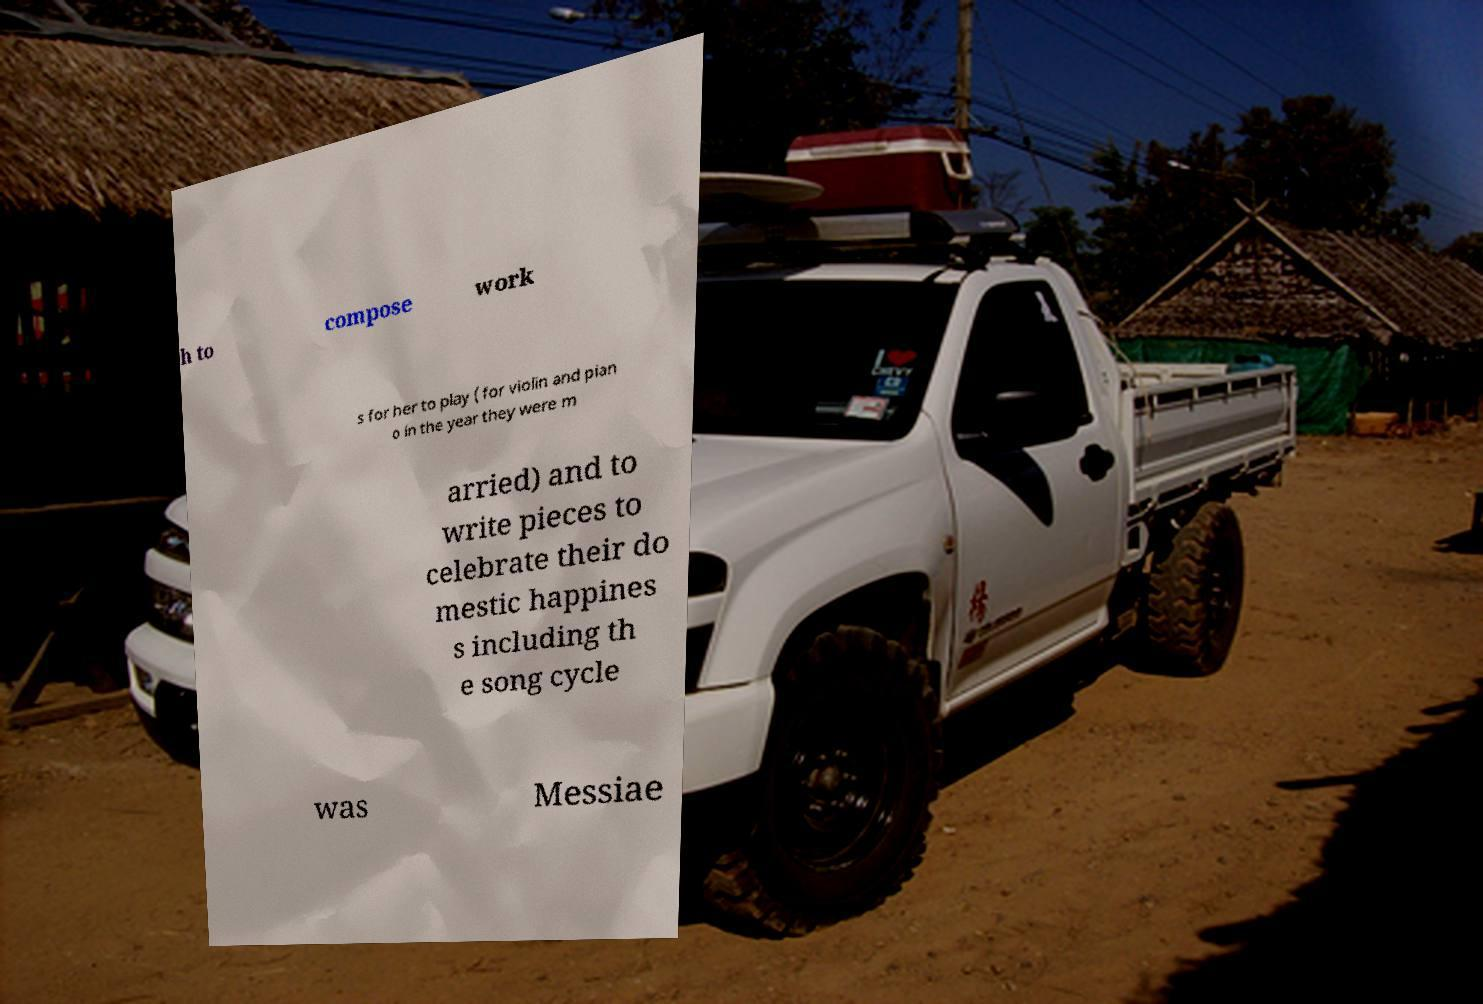Can you accurately transcribe the text from the provided image for me? h to compose work s for her to play ( for violin and pian o in the year they were m arried) and to write pieces to celebrate their do mestic happines s including th e song cycle was Messiae 